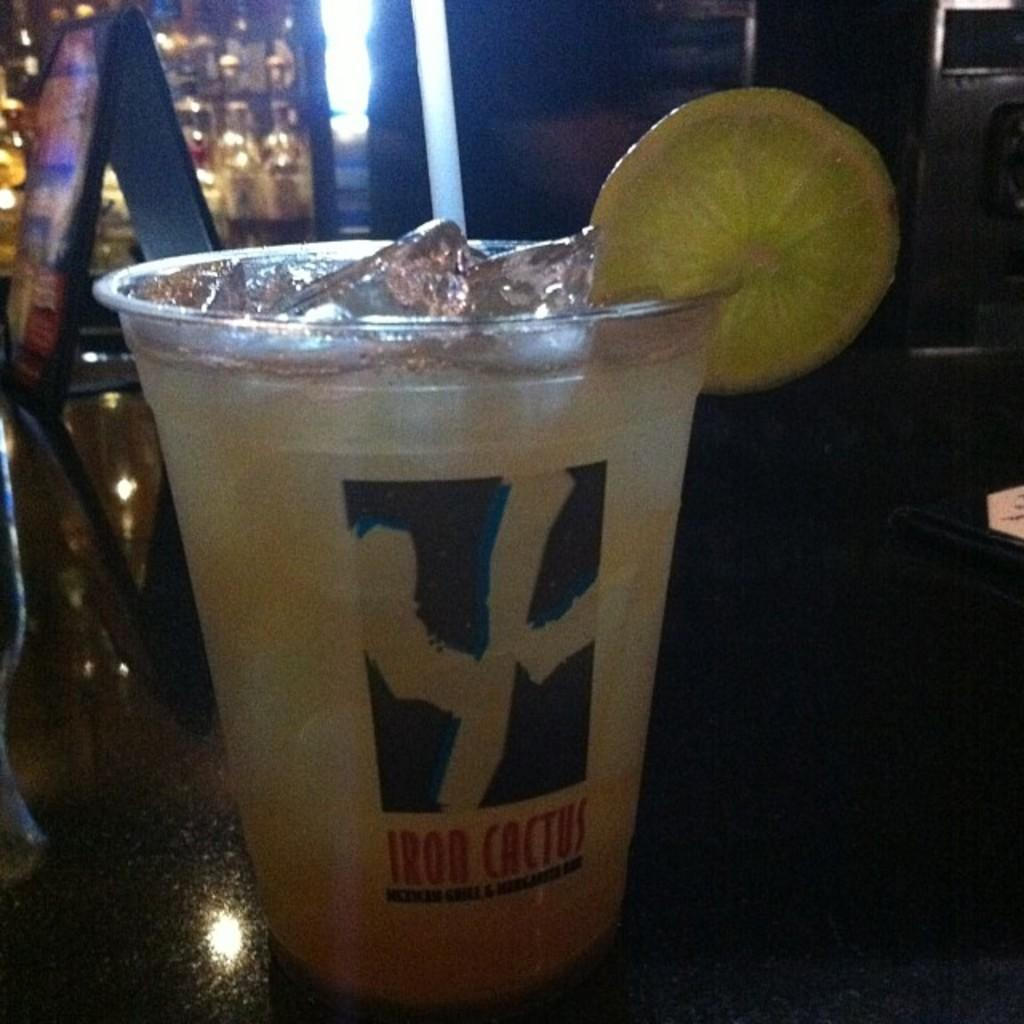What is in the glass that is visible in the image? There is a beverage in the image, and a lemon is also placed in the glass. What type of fruit is in the glass? The fruit in the glass is a lemon. Where is the glass with the beverage and lemon located? The glass with the beverage and lemon is placed on a table. How many worms can be seen crawling on the lemon in the image? There are no worms present in the image; it features a glass with a beverage and lemon. What type of debt is associated with the beverage in the image? There is no mention of any debt associated with the beverage in the image. 